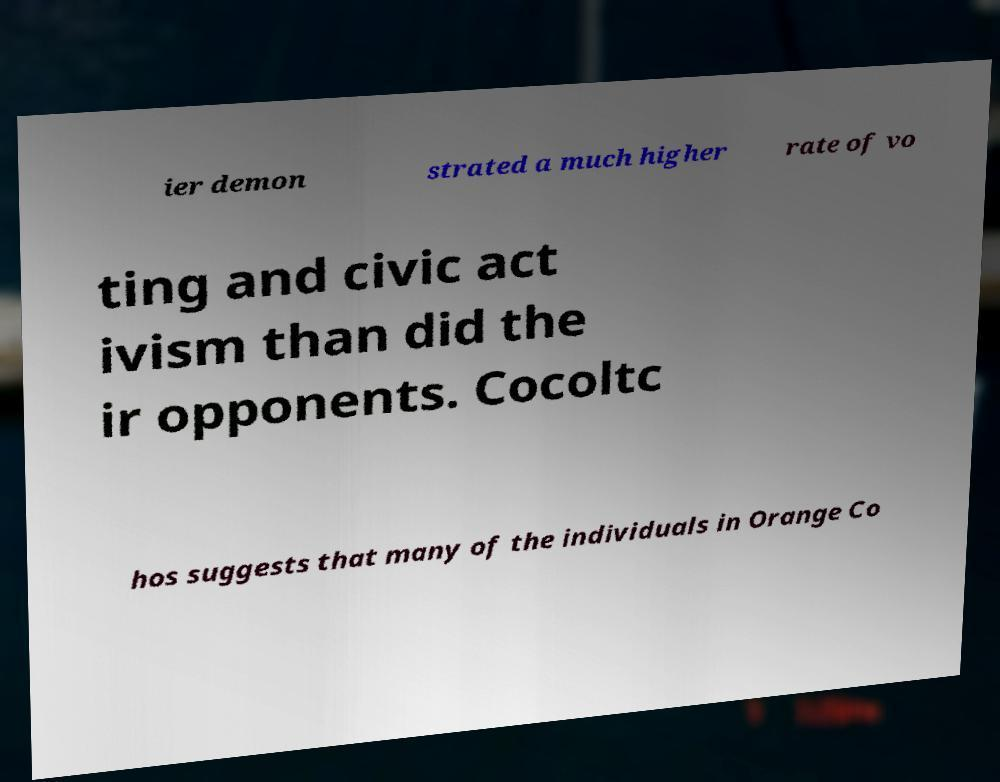Could you extract and type out the text from this image? ier demon strated a much higher rate of vo ting and civic act ivism than did the ir opponents. Cocoltc hos suggests that many of the individuals in Orange Co 